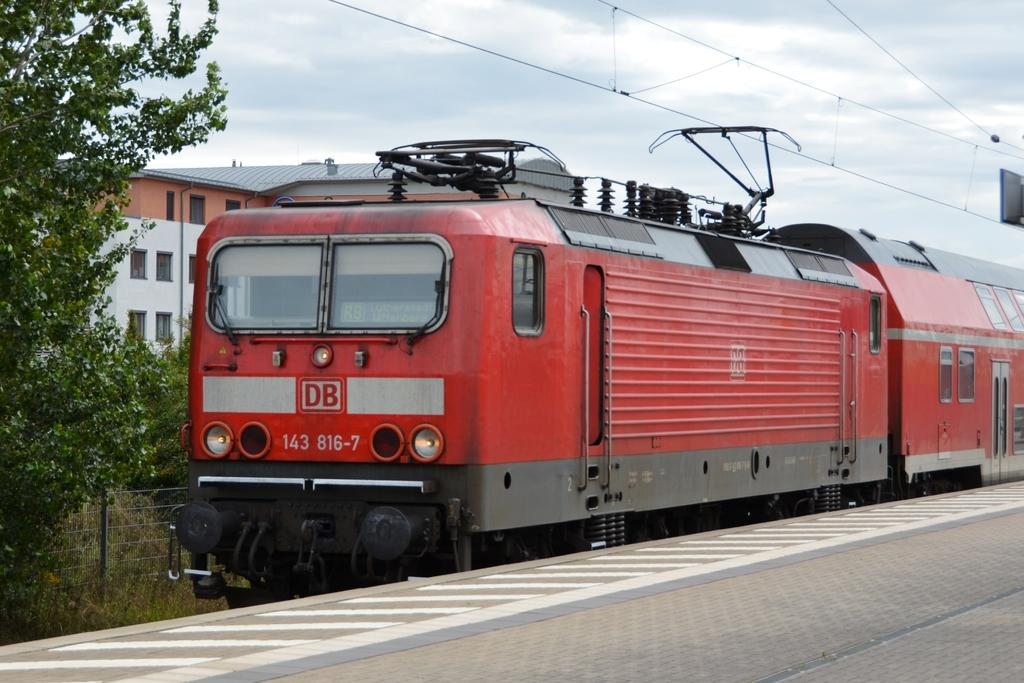<image>
Describe the image concisely. A red train with DB on the front car of it. 